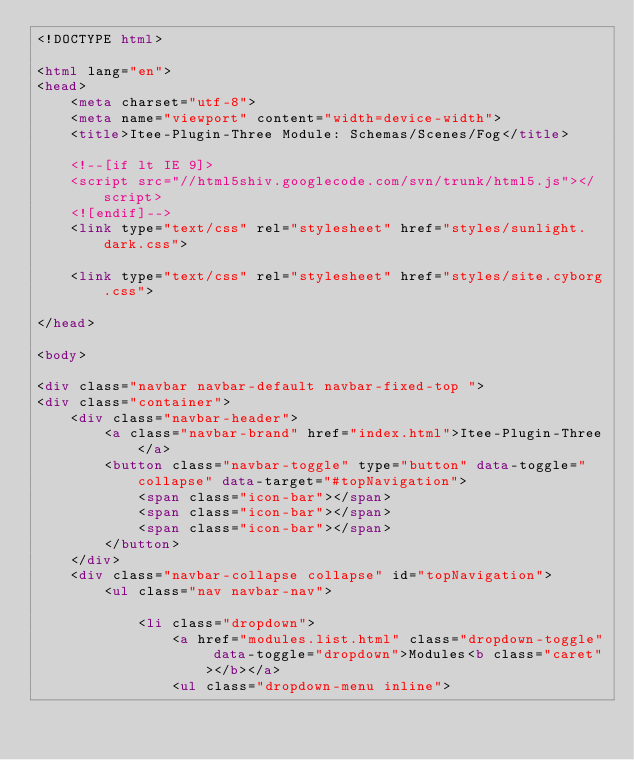<code> <loc_0><loc_0><loc_500><loc_500><_HTML_><!DOCTYPE html>

<html lang="en">
<head>
	<meta charset="utf-8">
	<meta name="viewport" content="width=device-width">
	<title>Itee-Plugin-Three Module: Schemas/Scenes/Fog</title>

	<!--[if lt IE 9]>
	<script src="//html5shiv.googlecode.com/svn/trunk/html5.js"></script>
	<![endif]-->
	<link type="text/css" rel="stylesheet" href="styles/sunlight.dark.css">

	<link type="text/css" rel="stylesheet" href="styles/site.cyborg.css">

</head>

<body>

<div class="navbar navbar-default navbar-fixed-top ">
<div class="container">
	<div class="navbar-header">
		<a class="navbar-brand" href="index.html">Itee-Plugin-Three</a>
		<button class="navbar-toggle" type="button" data-toggle="collapse" data-target="#topNavigation">
			<span class="icon-bar"></span>
			<span class="icon-bar"></span>
			<span class="icon-bar"></span>
        </button>
	</div>
	<div class="navbar-collapse collapse" id="topNavigation">
		<ul class="nav navbar-nav">
			
			<li class="dropdown">
				<a href="modules.list.html" class="dropdown-toggle" data-toggle="dropdown">Modules<b class="caret"></b></a>
				<ul class="dropdown-menu inline"></code> 